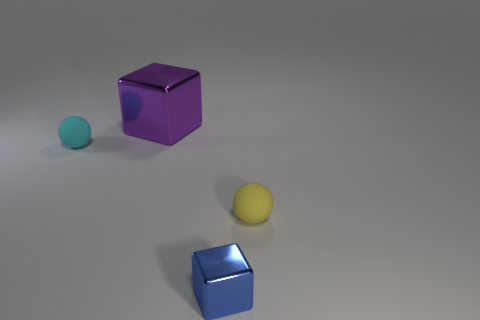Add 4 tiny blocks. How many objects exist? 8 Subtract all yellow spheres. How many spheres are left? 1 Subtract 1 purple blocks. How many objects are left? 3 Subtract 1 spheres. How many spheres are left? 1 Subtract all brown blocks. Subtract all brown cylinders. How many blocks are left? 2 Subtract all blue metal objects. Subtract all small blue objects. How many objects are left? 2 Add 4 cubes. How many cubes are left? 6 Add 3 big purple cubes. How many big purple cubes exist? 4 